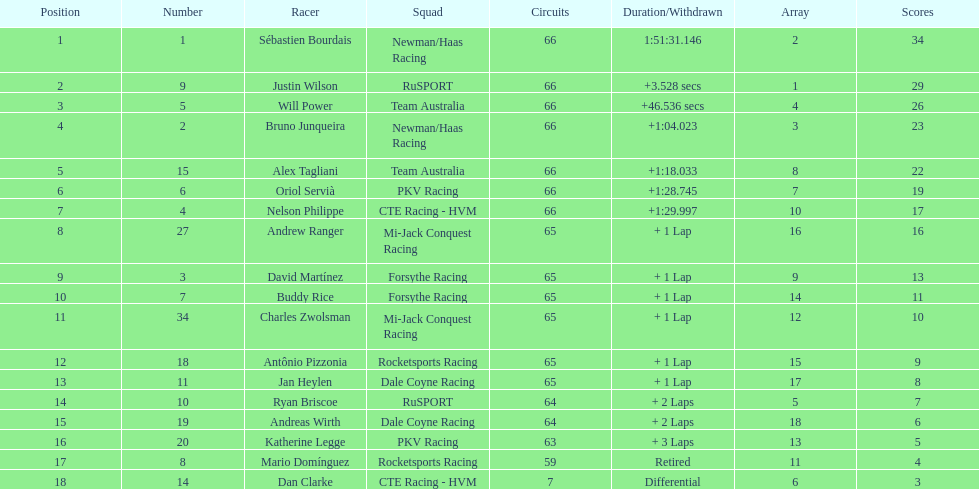Would you be able to parse every entry in this table? {'header': ['Position', 'Number', 'Racer', 'Squad', 'Circuits', 'Duration/Withdrawn', 'Array', 'Scores'], 'rows': [['1', '1', 'Sébastien Bourdais', 'Newman/Haas Racing', '66', '1:51:31.146', '2', '34'], ['2', '9', 'Justin Wilson', 'RuSPORT', '66', '+3.528 secs', '1', '29'], ['3', '5', 'Will Power', 'Team Australia', '66', '+46.536 secs', '4', '26'], ['4', '2', 'Bruno Junqueira', 'Newman/Haas Racing', '66', '+1:04.023', '3', '23'], ['5', '15', 'Alex Tagliani', 'Team Australia', '66', '+1:18.033', '8', '22'], ['6', '6', 'Oriol Servià', 'PKV Racing', '66', '+1:28.745', '7', '19'], ['7', '4', 'Nelson Philippe', 'CTE Racing - HVM', '66', '+1:29.997', '10', '17'], ['8', '27', 'Andrew Ranger', 'Mi-Jack Conquest Racing', '65', '+ 1 Lap', '16', '16'], ['9', '3', 'David Martínez', 'Forsythe Racing', '65', '+ 1 Lap', '9', '13'], ['10', '7', 'Buddy Rice', 'Forsythe Racing', '65', '+ 1 Lap', '14', '11'], ['11', '34', 'Charles Zwolsman', 'Mi-Jack Conquest Racing', '65', '+ 1 Lap', '12', '10'], ['12', '18', 'Antônio Pizzonia', 'Rocketsports Racing', '65', '+ 1 Lap', '15', '9'], ['13', '11', 'Jan Heylen', 'Dale Coyne Racing', '65', '+ 1 Lap', '17', '8'], ['14', '10', 'Ryan Briscoe', 'RuSPORT', '64', '+ 2 Laps', '5', '7'], ['15', '19', 'Andreas Wirth', 'Dale Coyne Racing', '64', '+ 2 Laps', '18', '6'], ['16', '20', 'Katherine Legge', 'PKV Racing', '63', '+ 3 Laps', '13', '5'], ['17', '8', 'Mario Domínguez', 'Rocketsports Racing', '59', 'Retired', '11', '4'], ['18', '14', 'Dan Clarke', 'CTE Racing - HVM', '7', 'Differential', '6', '3']]} At the 2006 gran premio telmex, how many drivers completed less than 60 laps? 2. 